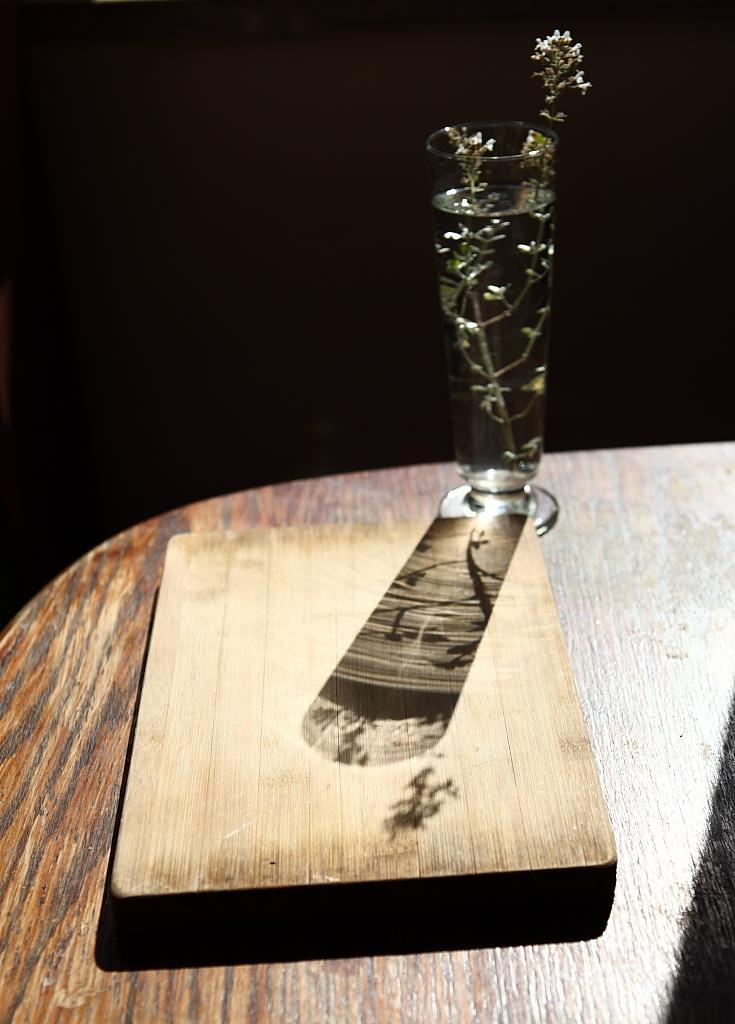Can you describe this image briefly? In this image in front there is a table. On top of it there is a flower vase and a wooden box. 